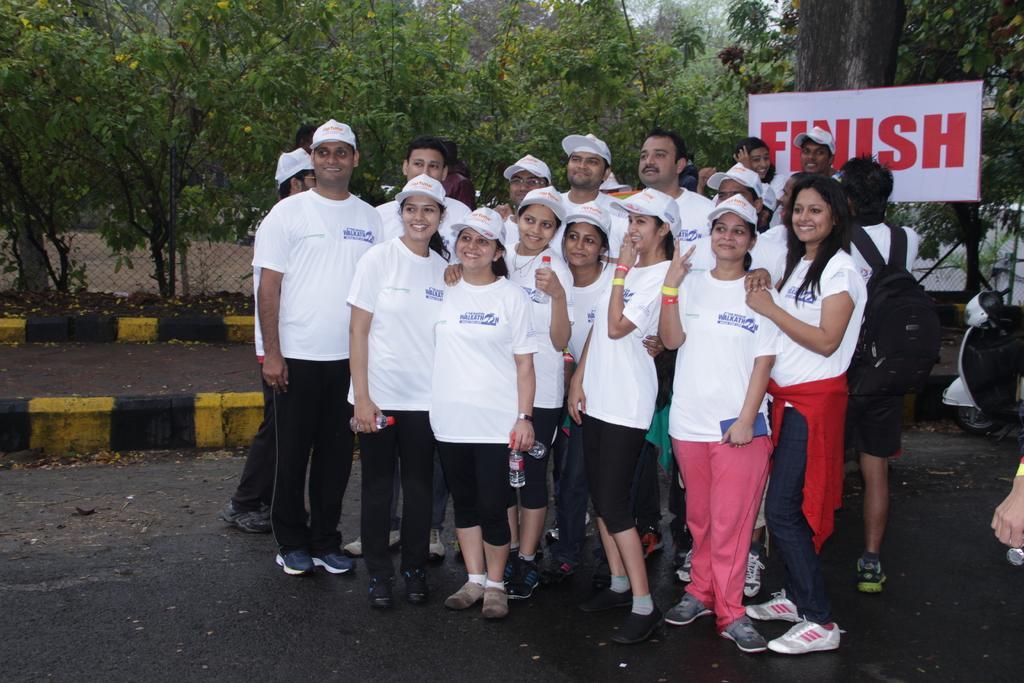Describe this image in one or two sentences. In this image I can see group of people standing wearing white shirt, black pant. Background I can see white color banner, trees in green color and sky in white color. 